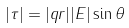Convert formula to latex. <formula><loc_0><loc_0><loc_500><loc_500>| \tau | = | q r | | E | \sin \theta</formula> 